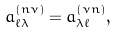Convert formula to latex. <formula><loc_0><loc_0><loc_500><loc_500>a _ { \ell \lambda } ^ { ( n \nu ) } = a _ { \lambda \ell } ^ { ( \nu n ) } ,</formula> 